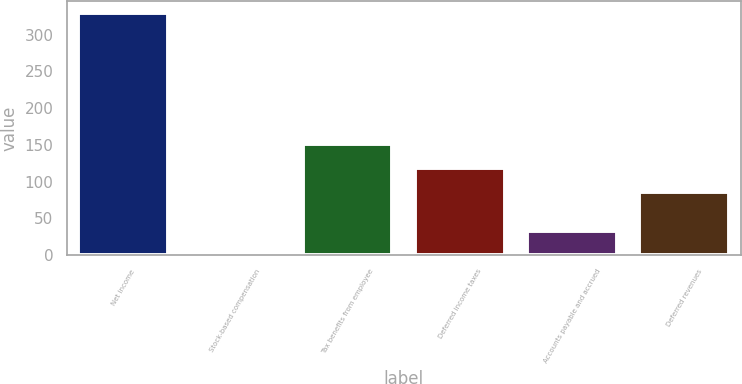<chart> <loc_0><loc_0><loc_500><loc_500><bar_chart><fcel>Net income<fcel>Stock-based compensation<fcel>Tax benefits from employee<fcel>Deferred income taxes<fcel>Accounts payable and accrued<fcel>Deferred revenues<nl><fcel>328.9<fcel>0.4<fcel>151.4<fcel>118.55<fcel>33.25<fcel>85.7<nl></chart> 